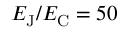<formula> <loc_0><loc_0><loc_500><loc_500>E _ { J } / E _ { C } = 5 0</formula> 